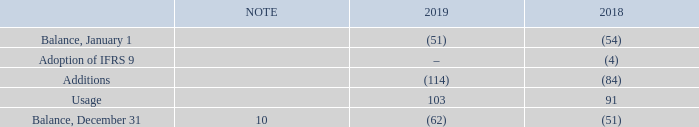CREDIT RISK
We are exposed to credit risk from operating activities and certain financing activities, the maximum exposure of which is represented by the carrying amounts reported in the statements of financial position.
We are exposed to credit risk if counterparties to our trade receivables and derivative instruments are unable to meet their obligations. The concentration of credit risk from our customers is minimized because we have a large and diverse customer base. There was minimal credit risk relating to derivative instruments at December 31, 2019 and 2018. We deal with institutions that have investment-grade credit ratings, and as such we expect that they will be able to meet their obligations. We regularly monitor our credit risk and credit exposure.
The following table provides the change in allowance for doubtful accounts for trade receivables.
How is the maximum exposure to credit risk represented? Represented by the carrying amounts reported in the statements of financial position. Why is the concentration of credit risk from customers minimized? Because we have a large and diverse customer base. What are the periods considered in this context? 2019, 2018. Which year was the amount for Usage larger? 103>91
Answer: 2019. What is the change in the amount for Usage in 2019? 103-91
Answer: 12. What is the average amount of Usage in 2018 and 2019? (103+91)/2
Answer: 97. 